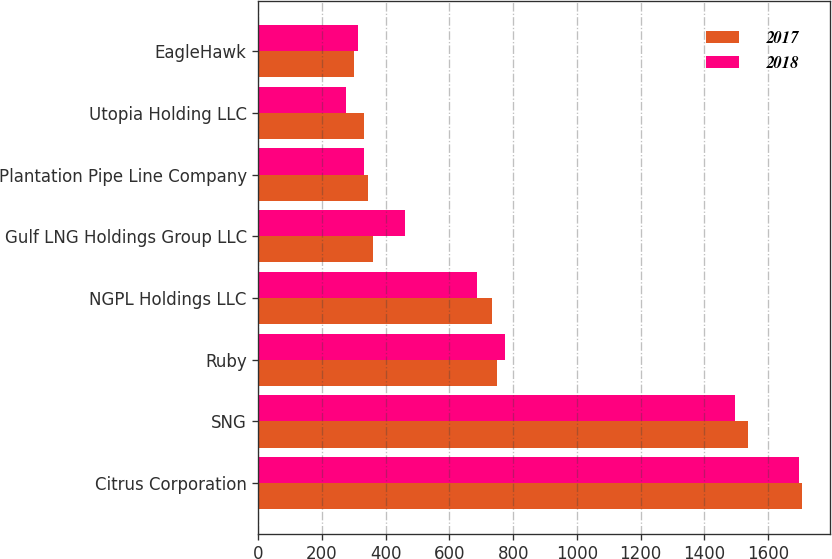<chart> <loc_0><loc_0><loc_500><loc_500><stacked_bar_chart><ecel><fcel>Citrus Corporation<fcel>SNG<fcel>Ruby<fcel>NGPL Holdings LLC<fcel>Gulf LNG Holdings Group LLC<fcel>Plantation Pipe Line Company<fcel>Utopia Holding LLC<fcel>EagleHawk<nl><fcel>2017<fcel>1708<fcel>1536<fcel>750<fcel>733<fcel>361<fcel>344<fcel>333<fcel>299<nl><fcel>2018<fcel>1698<fcel>1495<fcel>774<fcel>687<fcel>461<fcel>331<fcel>276<fcel>314<nl></chart> 